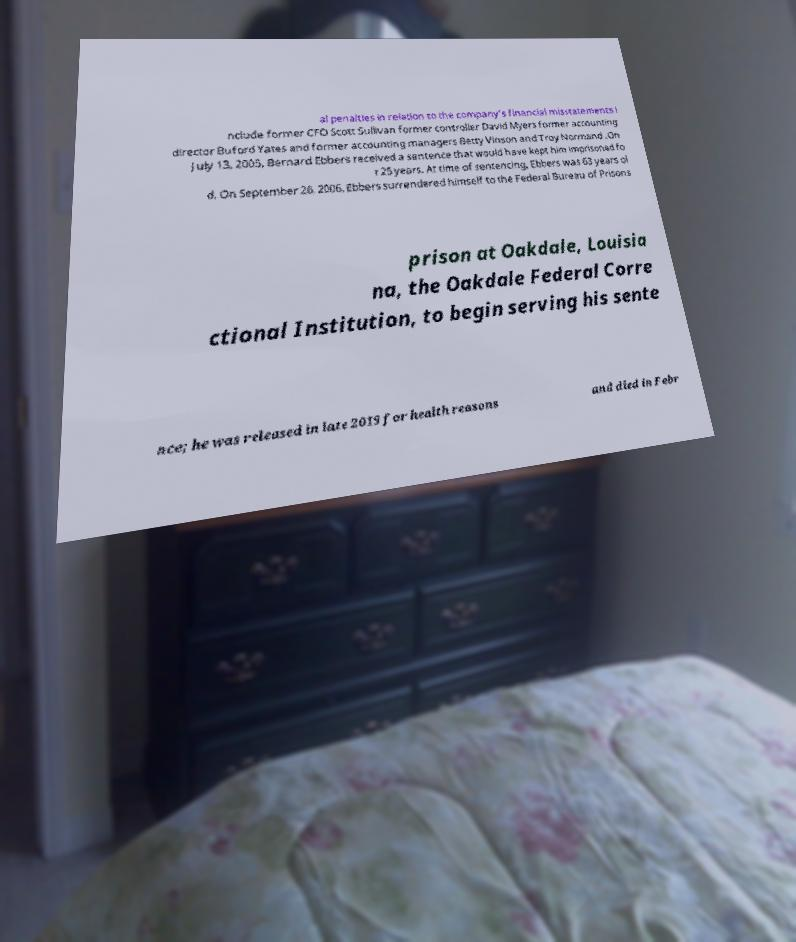For documentation purposes, I need the text within this image transcribed. Could you provide that? al penalties in relation to the company's financial misstatements i nclude former CFO Scott Sullivan former controller David Myers former accounting director Buford Yates and former accounting managers Betty Vinson and Troy Normand .On July 13, 2005, Bernard Ebbers received a sentence that would have kept him imprisoned fo r 25 years. At time of sentencing, Ebbers was 63 years ol d. On September 26, 2006, Ebbers surrendered himself to the Federal Bureau of Prisons prison at Oakdale, Louisia na, the Oakdale Federal Corre ctional Institution, to begin serving his sente nce; he was released in late 2019 for health reasons and died in Febr 